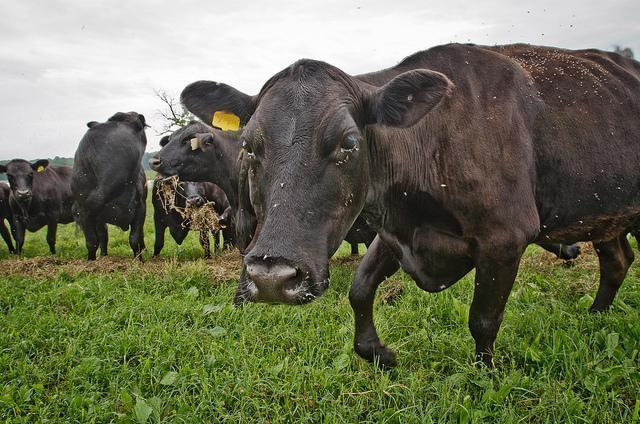How many cows are in the picture?
Give a very brief answer. 5. 